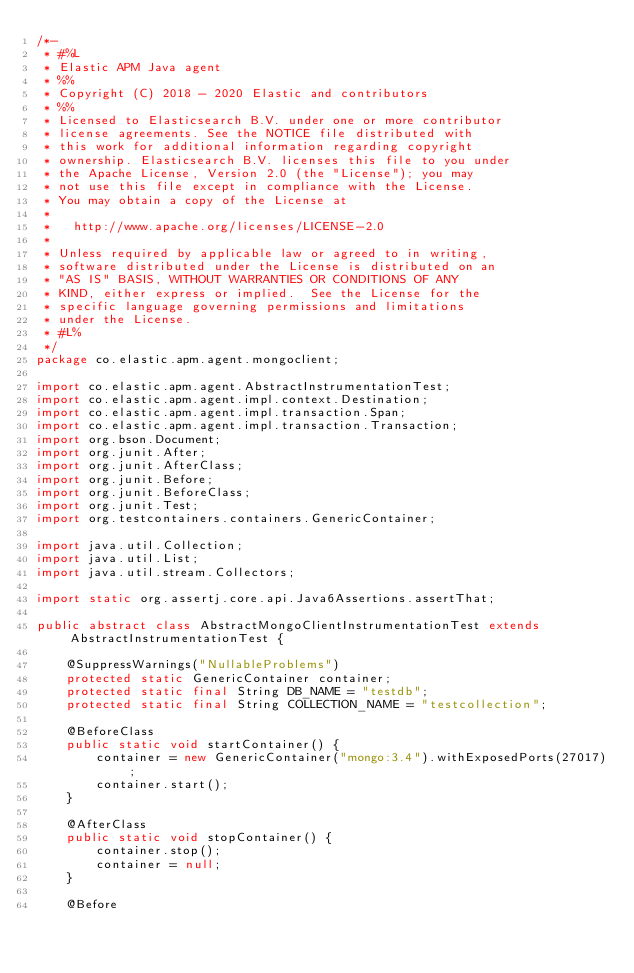Convert code to text. <code><loc_0><loc_0><loc_500><loc_500><_Java_>/*-
 * #%L
 * Elastic APM Java agent
 * %%
 * Copyright (C) 2018 - 2020 Elastic and contributors
 * %%
 * Licensed to Elasticsearch B.V. under one or more contributor
 * license agreements. See the NOTICE file distributed with
 * this work for additional information regarding copyright
 * ownership. Elasticsearch B.V. licenses this file to you under
 * the Apache License, Version 2.0 (the "License"); you may
 * not use this file except in compliance with the License.
 * You may obtain a copy of the License at
 *
 *   http://www.apache.org/licenses/LICENSE-2.0
 *
 * Unless required by applicable law or agreed to in writing,
 * software distributed under the License is distributed on an
 * "AS IS" BASIS, WITHOUT WARRANTIES OR CONDITIONS OF ANY
 * KIND, either express or implied.  See the License for the
 * specific language governing permissions and limitations
 * under the License.
 * #L%
 */
package co.elastic.apm.agent.mongoclient;

import co.elastic.apm.agent.AbstractInstrumentationTest;
import co.elastic.apm.agent.impl.context.Destination;
import co.elastic.apm.agent.impl.transaction.Span;
import co.elastic.apm.agent.impl.transaction.Transaction;
import org.bson.Document;
import org.junit.After;
import org.junit.AfterClass;
import org.junit.Before;
import org.junit.BeforeClass;
import org.junit.Test;
import org.testcontainers.containers.GenericContainer;

import java.util.Collection;
import java.util.List;
import java.util.stream.Collectors;

import static org.assertj.core.api.Java6Assertions.assertThat;

public abstract class AbstractMongoClientInstrumentationTest extends AbstractInstrumentationTest {

    @SuppressWarnings("NullableProblems")
    protected static GenericContainer container;
    protected static final String DB_NAME = "testdb";
    protected static final String COLLECTION_NAME = "testcollection";

    @BeforeClass
    public static void startContainer() {
        container = new GenericContainer("mongo:3.4").withExposedPorts(27017);
        container.start();
    }

    @AfterClass
    public static void stopContainer() {
        container.stop();
        container = null;
    }

    @Before</code> 